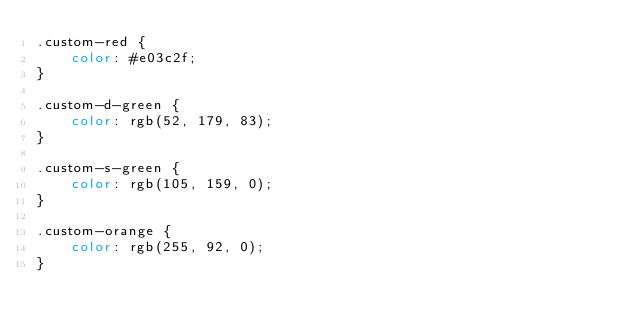Convert code to text. <code><loc_0><loc_0><loc_500><loc_500><_CSS_>.custom-red {
    color: #e03c2f;
}

.custom-d-green {
    color: rgb(52, 179, 83);
}

.custom-s-green {
    color: rgb(105, 159, 0);
}

.custom-orange {
    color: rgb(255, 92, 0);
}</code> 